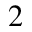Convert formula to latex. <formula><loc_0><loc_0><loc_500><loc_500>^ { 2 }</formula> 